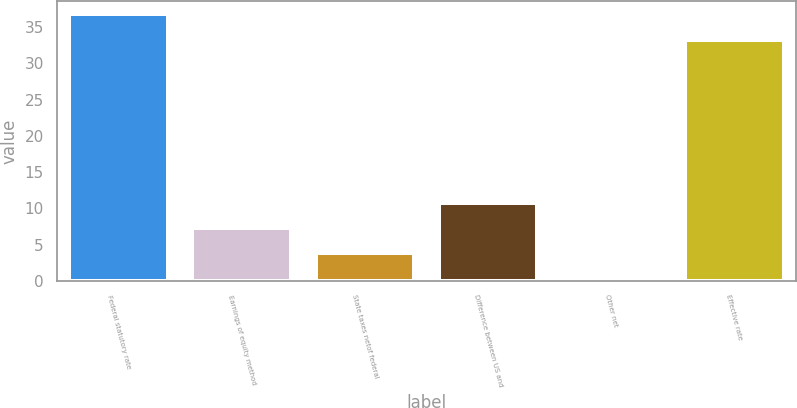<chart> <loc_0><loc_0><loc_500><loc_500><bar_chart><fcel>Federal statutory rate<fcel>Earnings of equity method<fcel>State taxes netof federal<fcel>Difference between US and<fcel>Other net<fcel>Effective rate<nl><fcel>36.76<fcel>7.32<fcel>3.86<fcel>10.78<fcel>0.4<fcel>33.3<nl></chart> 